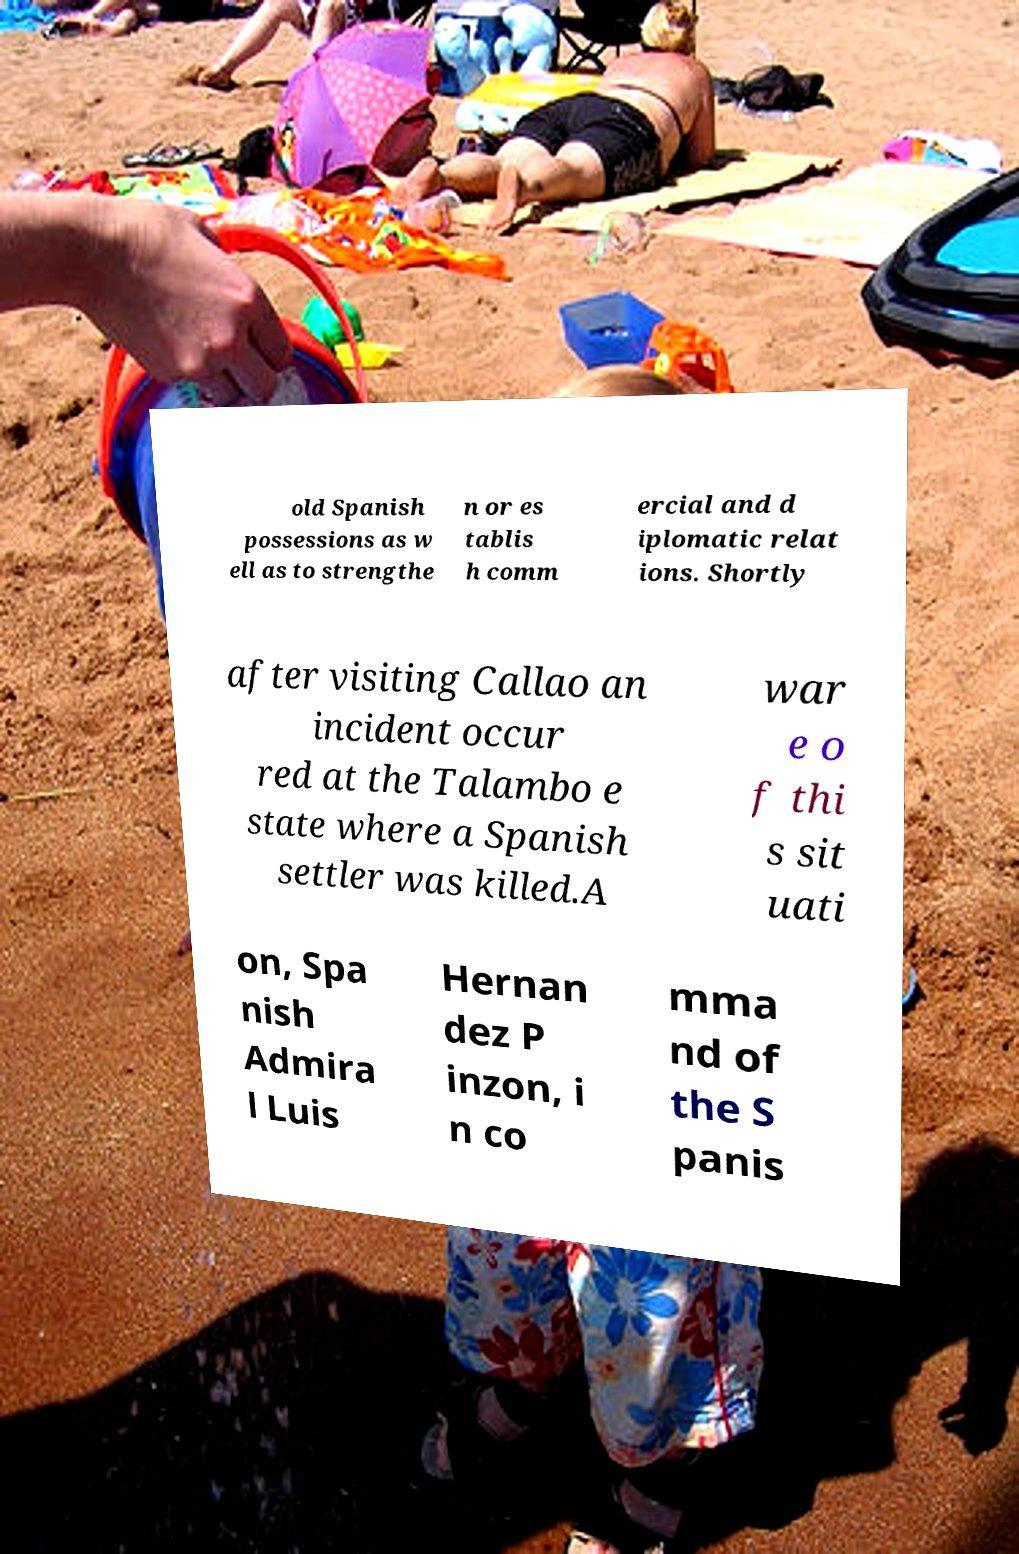There's text embedded in this image that I need extracted. Can you transcribe it verbatim? old Spanish possessions as w ell as to strengthe n or es tablis h comm ercial and d iplomatic relat ions. Shortly after visiting Callao an incident occur red at the Talambo e state where a Spanish settler was killed.A war e o f thi s sit uati on, Spa nish Admira l Luis Hernan dez P inzon, i n co mma nd of the S panis 